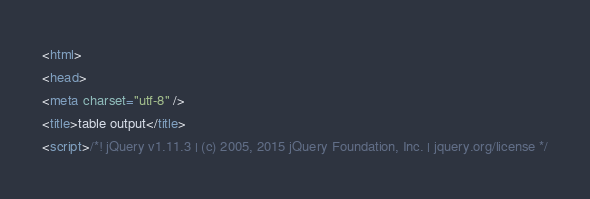Convert code to text. <code><loc_0><loc_0><loc_500><loc_500><_HTML_><html>
<head>
<meta charset="utf-8" />
<title>table output</title>
<script>/*! jQuery v1.11.3 | (c) 2005, 2015 jQuery Foundation, Inc. | jquery.org/license */</code> 